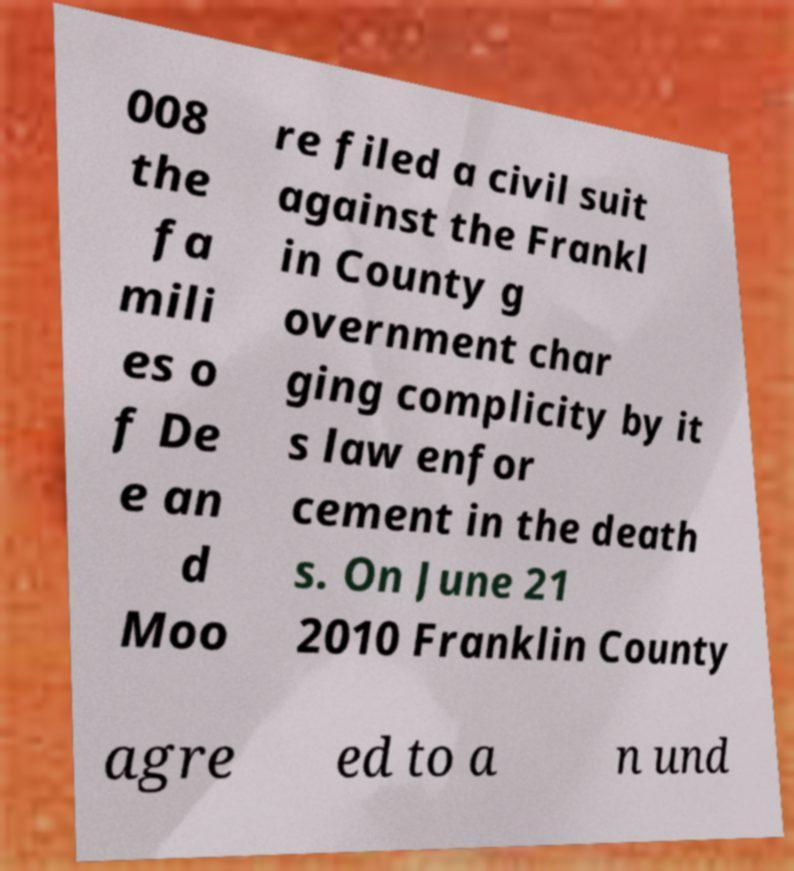There's text embedded in this image that I need extracted. Can you transcribe it verbatim? 008 the fa mili es o f De e an d Moo re filed a civil suit against the Frankl in County g overnment char ging complicity by it s law enfor cement in the death s. On June 21 2010 Franklin County agre ed to a n und 